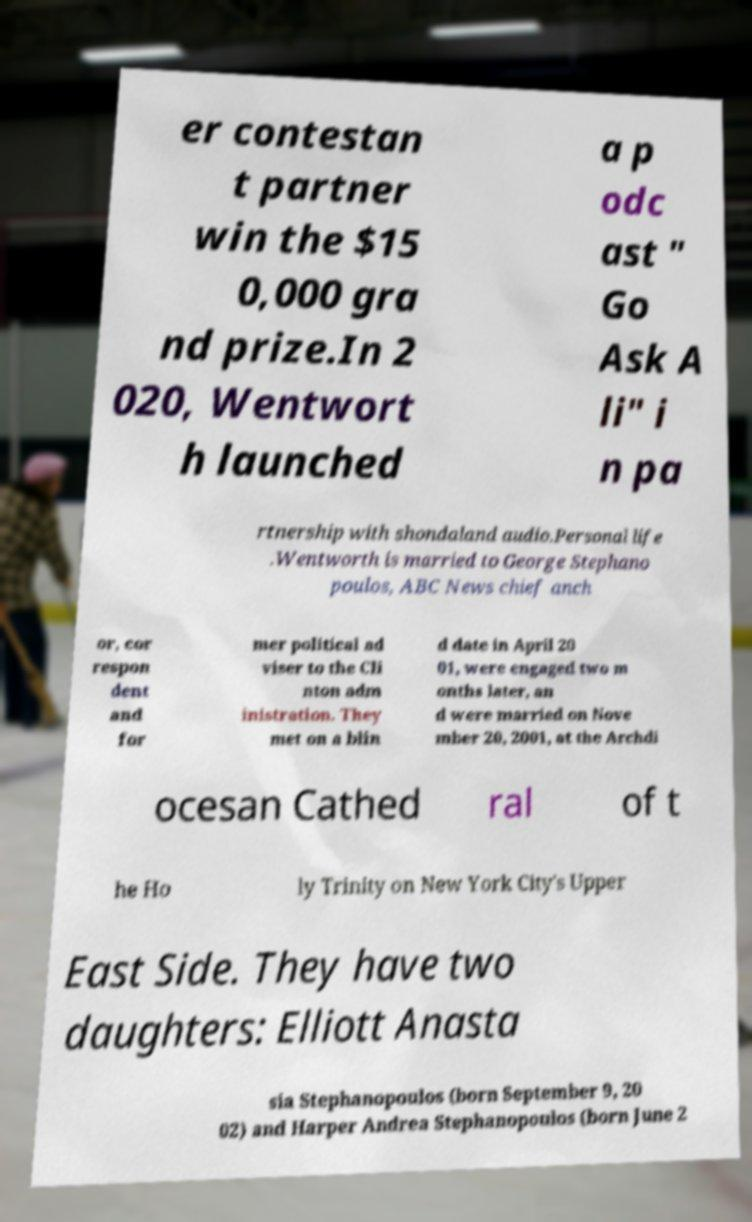I need the written content from this picture converted into text. Can you do that? er contestan t partner win the $15 0,000 gra nd prize.In 2 020, Wentwort h launched a p odc ast " Go Ask A li" i n pa rtnership with shondaland audio.Personal life .Wentworth is married to George Stephano poulos, ABC News chief anch or, cor respon dent and for mer political ad viser to the Cli nton adm inistration. They met on a blin d date in April 20 01, were engaged two m onths later, an d were married on Nove mber 20, 2001, at the Archdi ocesan Cathed ral of t he Ho ly Trinity on New York City's Upper East Side. They have two daughters: Elliott Anasta sia Stephanopoulos (born September 9, 20 02) and Harper Andrea Stephanopoulos (born June 2 